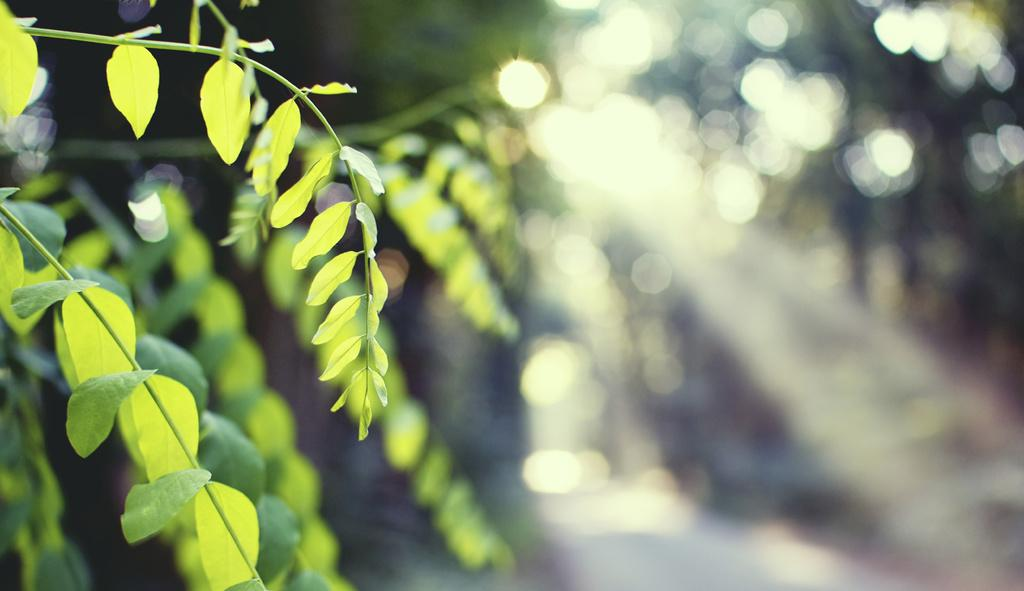What is located on the left side of the image? There is a tree on the left side of the image. What can be observed about the background and right side of the image? The background and right side of the image are blurred. What type of stem can be seen growing from the cabbage in the image? There is no cabbage or stem present in the image; it features a tree on the left side. How does the credit appear in the image? There is no credit or financial information present in the image. 